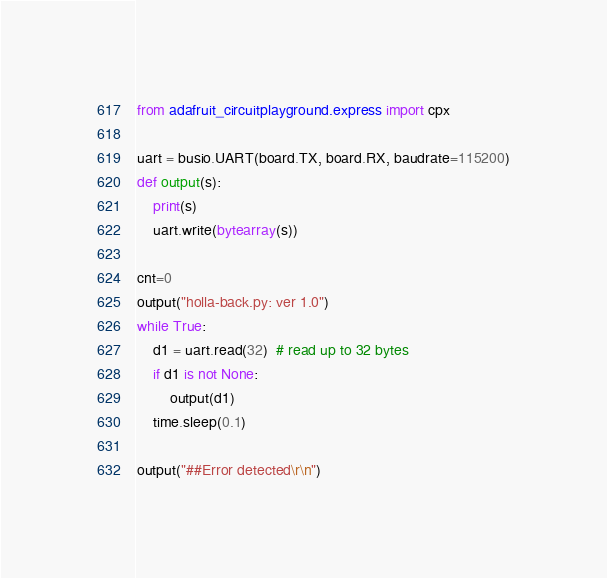<code> <loc_0><loc_0><loc_500><loc_500><_Python_>
from adafruit_circuitplayground.express import cpx

uart = busio.UART(board.TX, board.RX, baudrate=115200)
def output(s):
    print(s)
    uart.write(bytearray(s))

cnt=0
output("holla-back.py: ver 1.0")
while True:
    d1 = uart.read(32)  # read up to 32 bytes
    if d1 is not None:
        output(d1)
    time.sleep(0.1)

output("##Error detected\r\n")</code> 